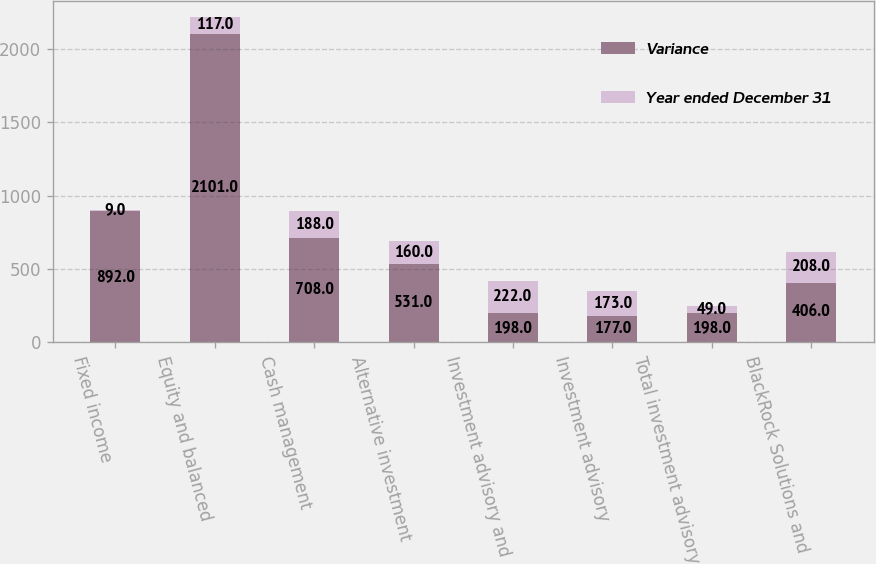<chart> <loc_0><loc_0><loc_500><loc_500><stacked_bar_chart><ecel><fcel>Fixed income<fcel>Equity and balanced<fcel>Cash management<fcel>Alternative investment<fcel>Investment advisory and<fcel>Investment advisory<fcel>Total investment advisory and<fcel>BlackRock Solutions and<nl><fcel>Variance<fcel>892<fcel>2101<fcel>708<fcel>531<fcel>198<fcel>177<fcel>198<fcel>406<nl><fcel>Year ended December 31<fcel>9<fcel>117<fcel>188<fcel>160<fcel>222<fcel>173<fcel>49<fcel>208<nl></chart> 